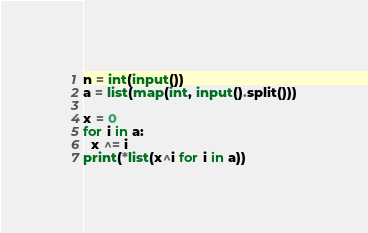<code> <loc_0><loc_0><loc_500><loc_500><_Python_>n = int(input())
a = list(map(int, input().split()))

x = 0
for i in a:
  x ^= i
print(*list(x^i for i in a))</code> 